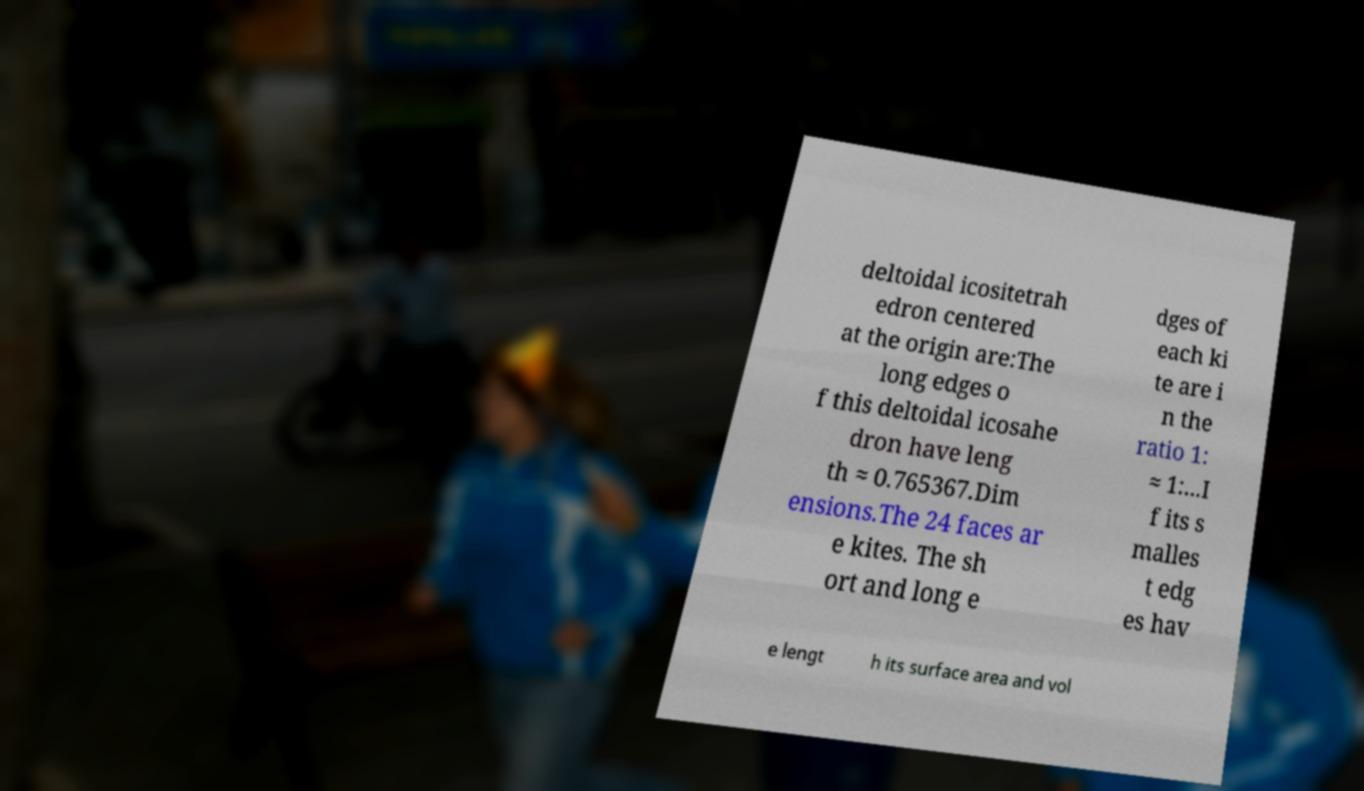I need the written content from this picture converted into text. Can you do that? deltoidal icositetrah edron centered at the origin are:The long edges o f this deltoidal icosahe dron have leng th ≈ 0.765367.Dim ensions.The 24 faces ar e kites. The sh ort and long e dges of each ki te are i n the ratio 1: ≈ 1:...I f its s malles t edg es hav e lengt h its surface area and vol 